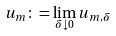<formula> <loc_0><loc_0><loc_500><loc_500>u _ { m } \colon = \lim _ { \delta \downarrow 0 } u _ { m , \delta }</formula> 